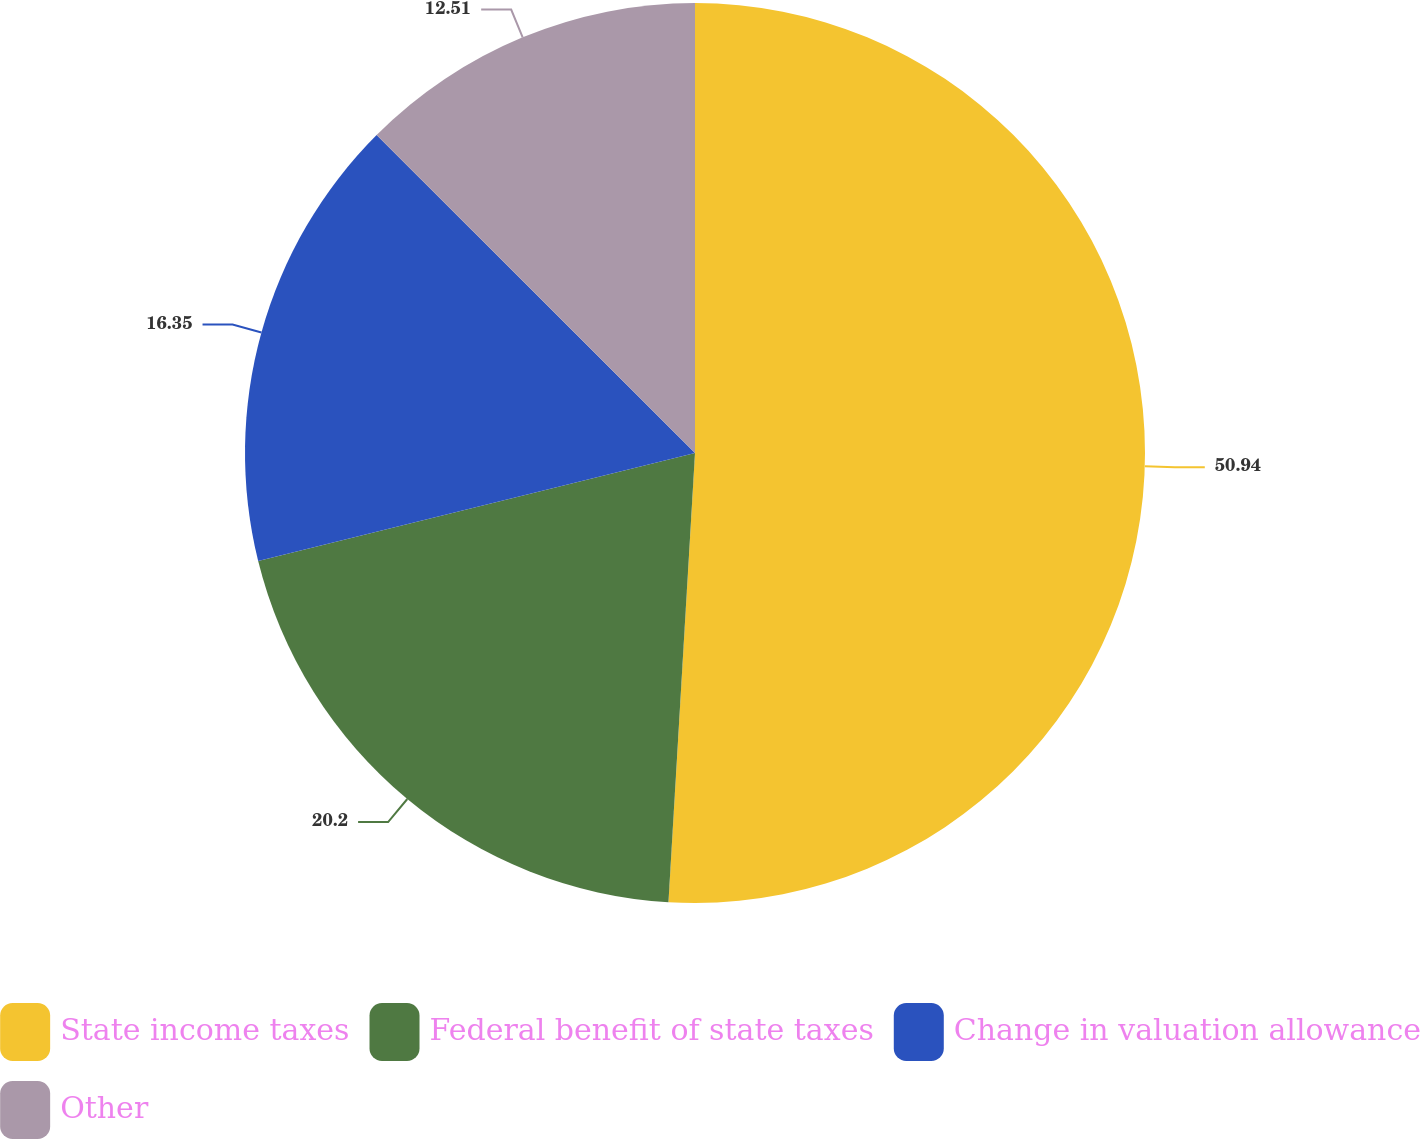Convert chart to OTSL. <chart><loc_0><loc_0><loc_500><loc_500><pie_chart><fcel>State income taxes<fcel>Federal benefit of state taxes<fcel>Change in valuation allowance<fcel>Other<nl><fcel>50.94%<fcel>20.2%<fcel>16.35%<fcel>12.51%<nl></chart> 